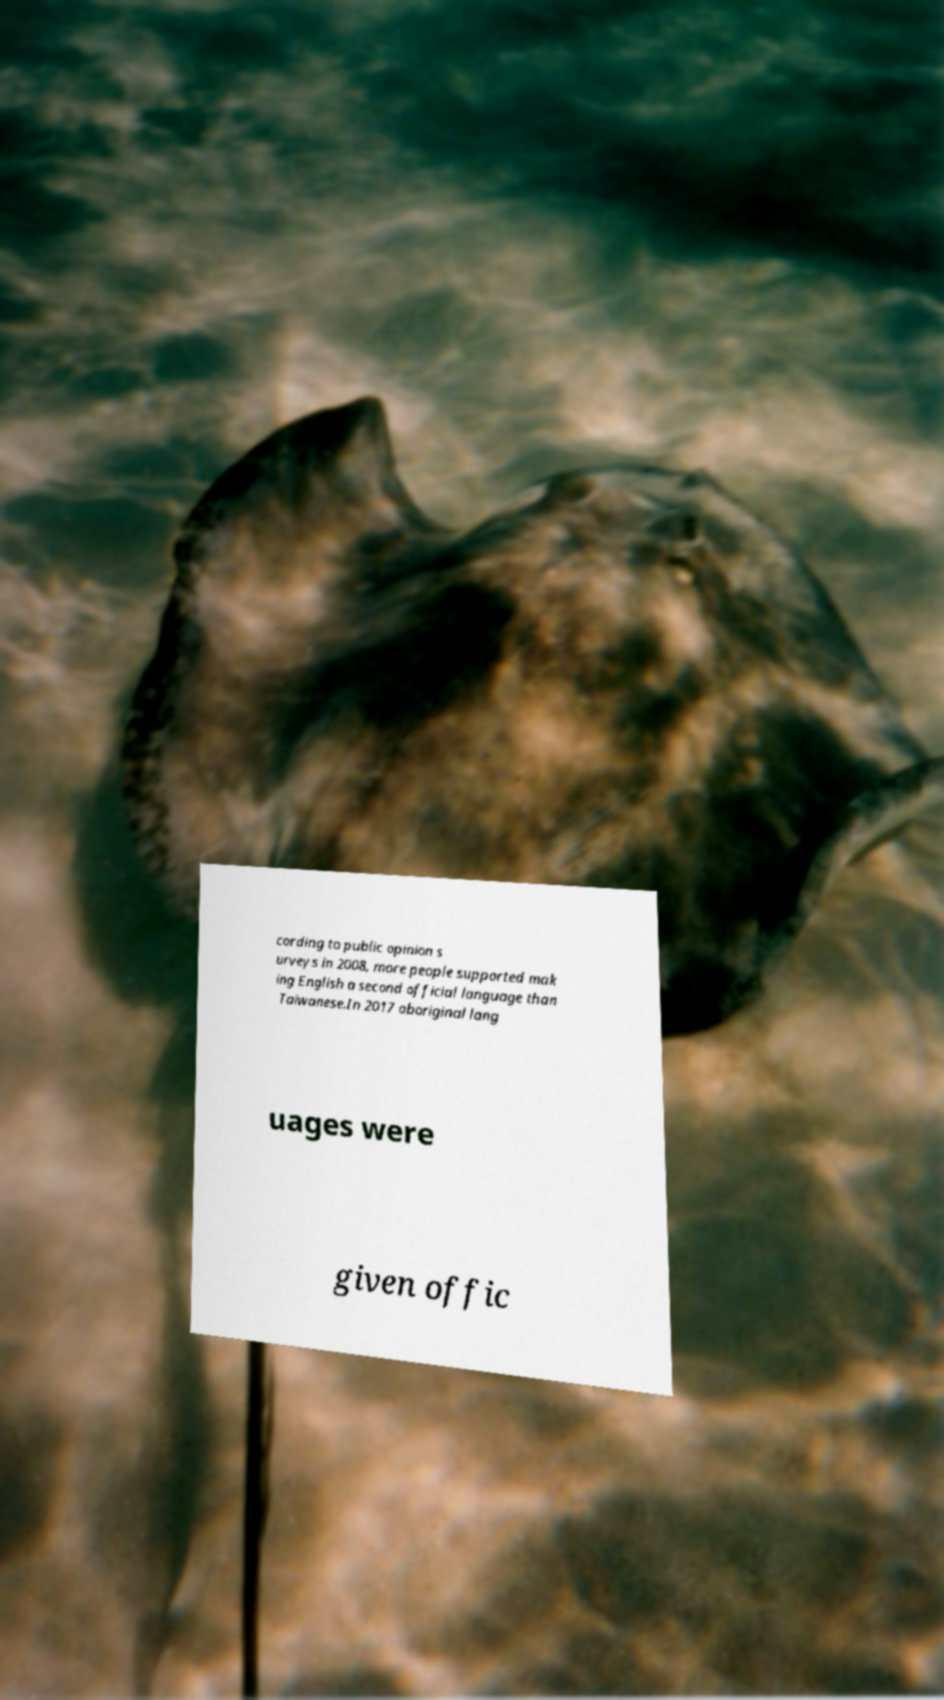What messages or text are displayed in this image? I need them in a readable, typed format. cording to public opinion s urveys in 2008, more people supported mak ing English a second official language than Taiwanese.In 2017 aboriginal lang uages were given offic 